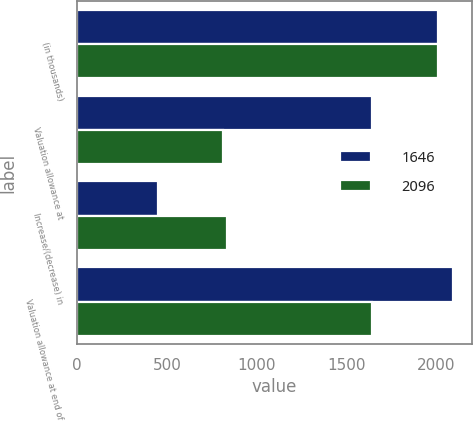<chart> <loc_0><loc_0><loc_500><loc_500><stacked_bar_chart><ecel><fcel>(in thousands)<fcel>Valuation allowance at<fcel>Increase/(decrease) in<fcel>Valuation allowance at end of<nl><fcel>1646<fcel>2012<fcel>1646<fcel>450<fcel>2096<nl><fcel>2096<fcel>2011<fcel>810<fcel>836<fcel>1646<nl></chart> 